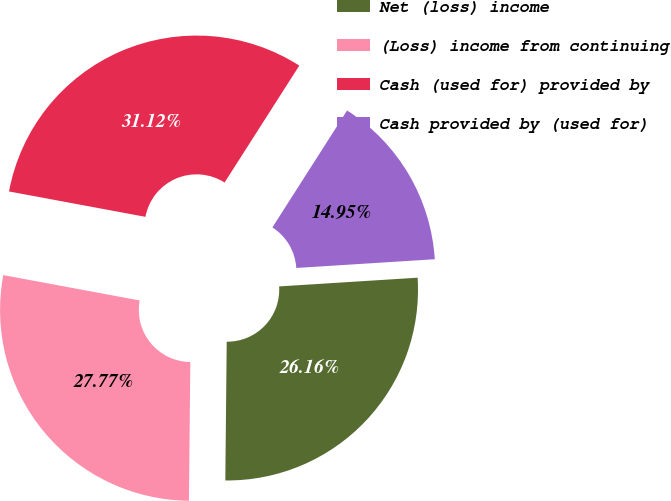Convert chart. <chart><loc_0><loc_0><loc_500><loc_500><pie_chart><fcel>Net (loss) income<fcel>(Loss) income from continuing<fcel>Cash (used for) provided by<fcel>Cash provided by (used for)<nl><fcel>26.16%<fcel>27.77%<fcel>31.12%<fcel>14.95%<nl></chart> 